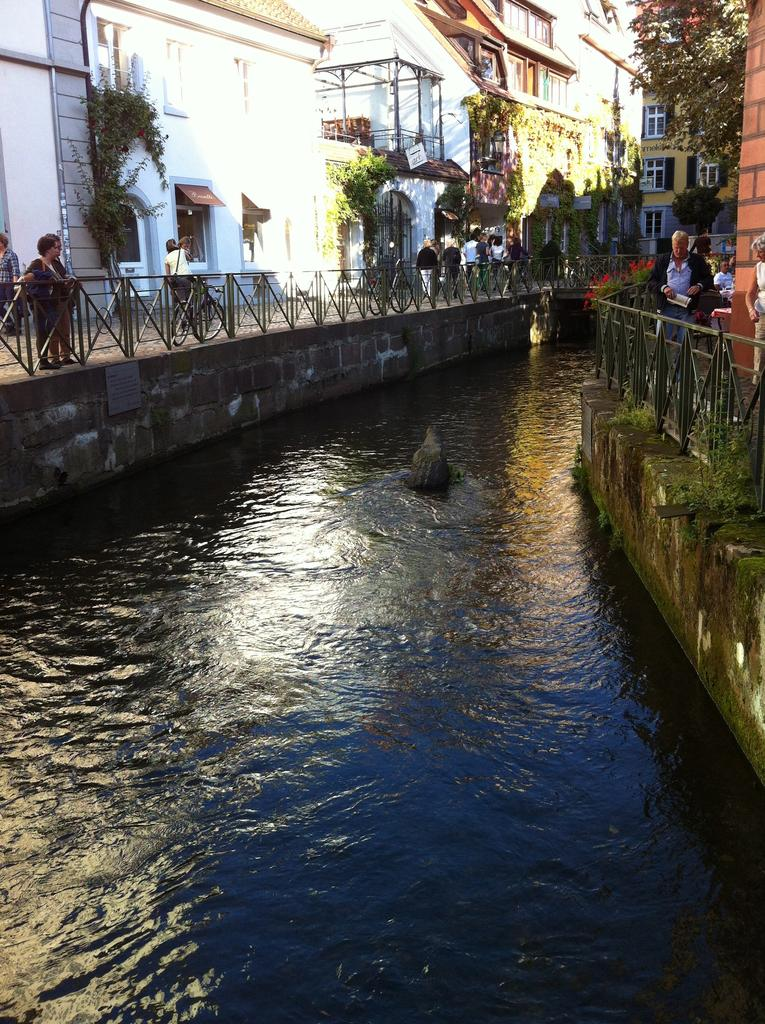What is in the water in the image? There is an animal in the water in the image. What are the people doing in the image? The people are standing on both sides of the water. What can be seen in the background of the image? There are buildings visible in the background. What type of can is being used by the animal in the image? There is no can present in the image; it features an animal in the water and people standing on both sides of the water. Who is the creator of the animal in the image? The image does not provide information about the creator of the animal; it simply depicts an animal in the water. 